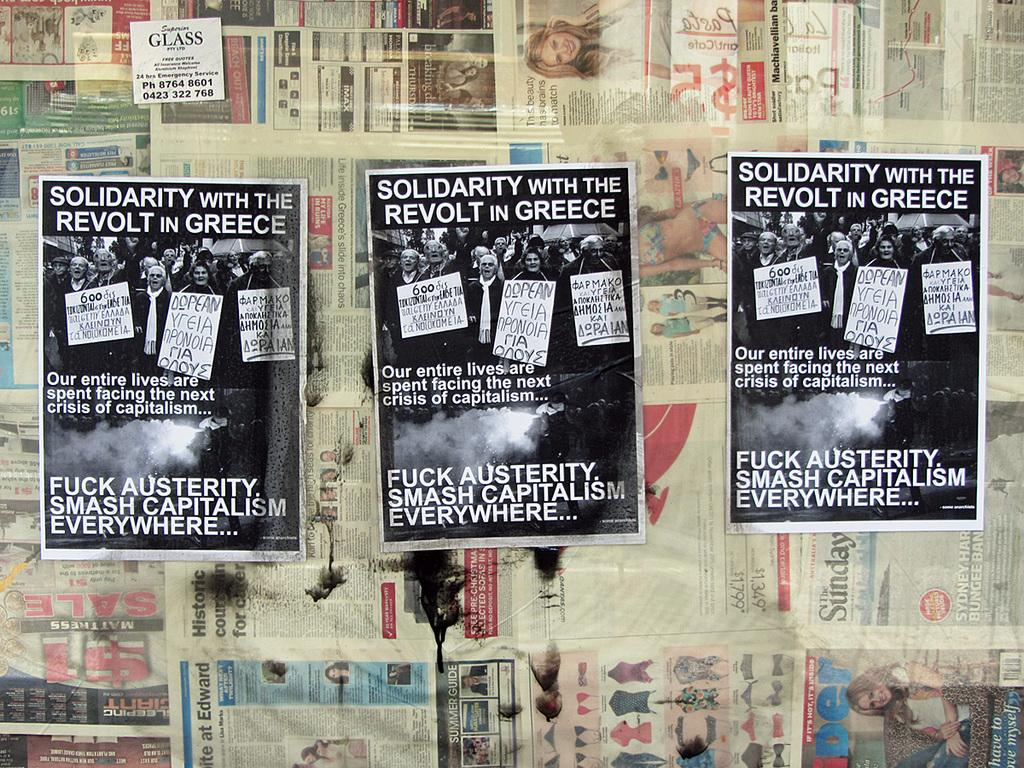<image>
Render a clear and concise summary of the photo. A poster asks for solidarity with the revolt in Greece. 